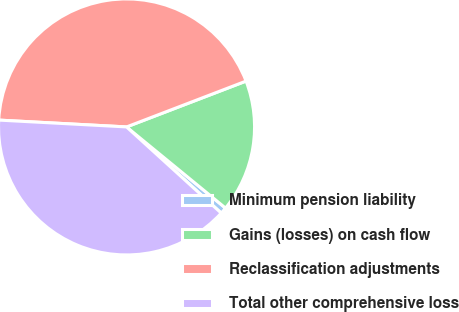Convert chart to OTSL. <chart><loc_0><loc_0><loc_500><loc_500><pie_chart><fcel>Minimum pension liability<fcel>Gains (losses) on cash flow<fcel>Reclassification adjustments<fcel>Total other comprehensive loss<nl><fcel>0.82%<fcel>16.76%<fcel>43.32%<fcel>39.1%<nl></chart> 